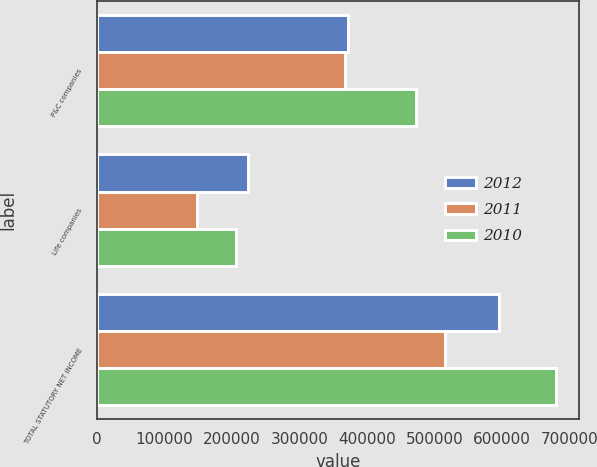Convert chart to OTSL. <chart><loc_0><loc_0><loc_500><loc_500><stacked_bar_chart><ecel><fcel>P&C companies<fcel>Life companies<fcel>TOTAL STATUTORY NET INCOME<nl><fcel>2012<fcel>371520<fcel>223519<fcel>595039<nl><fcel>2011<fcel>367315<fcel>148554<fcel>515869<nl><fcel>2010<fcel>473191<fcel>206817<fcel>680008<nl></chart> 